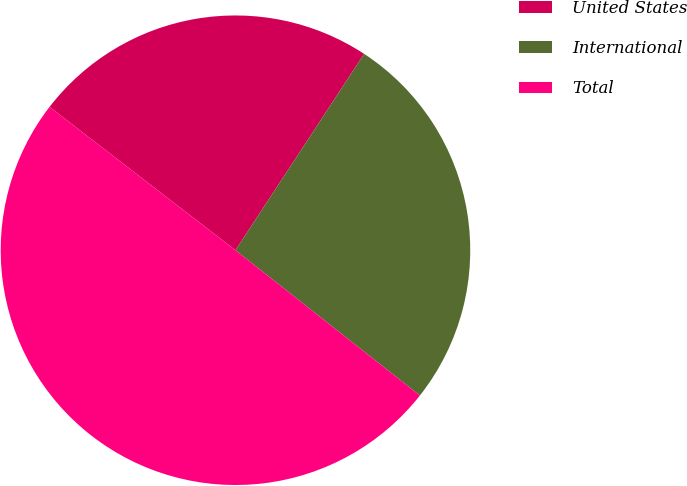Convert chart. <chart><loc_0><loc_0><loc_500><loc_500><pie_chart><fcel>United States<fcel>International<fcel>Total<nl><fcel>23.78%<fcel>26.39%<fcel>49.83%<nl></chart> 